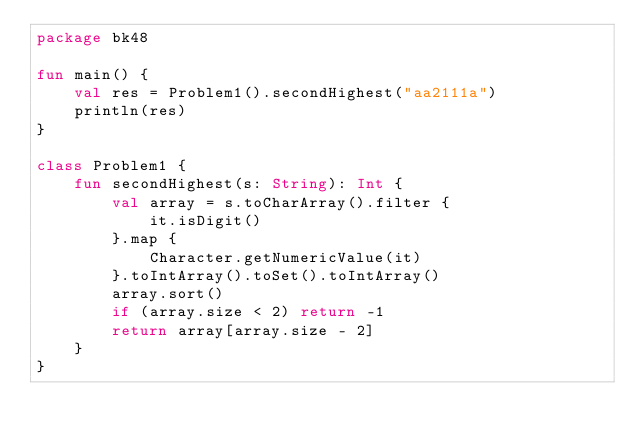Convert code to text. <code><loc_0><loc_0><loc_500><loc_500><_Kotlin_>package bk48

fun main() {
    val res = Problem1().secondHighest("aa2111a")
    println(res)
}

class Problem1 {
    fun secondHighest(s: String): Int {
        val array = s.toCharArray().filter {
            it.isDigit()
        }.map {
            Character.getNumericValue(it)
        }.toIntArray().toSet().toIntArray()
        array.sort()
        if (array.size < 2) return -1
        return array[array.size - 2]
    }
}
</code> 